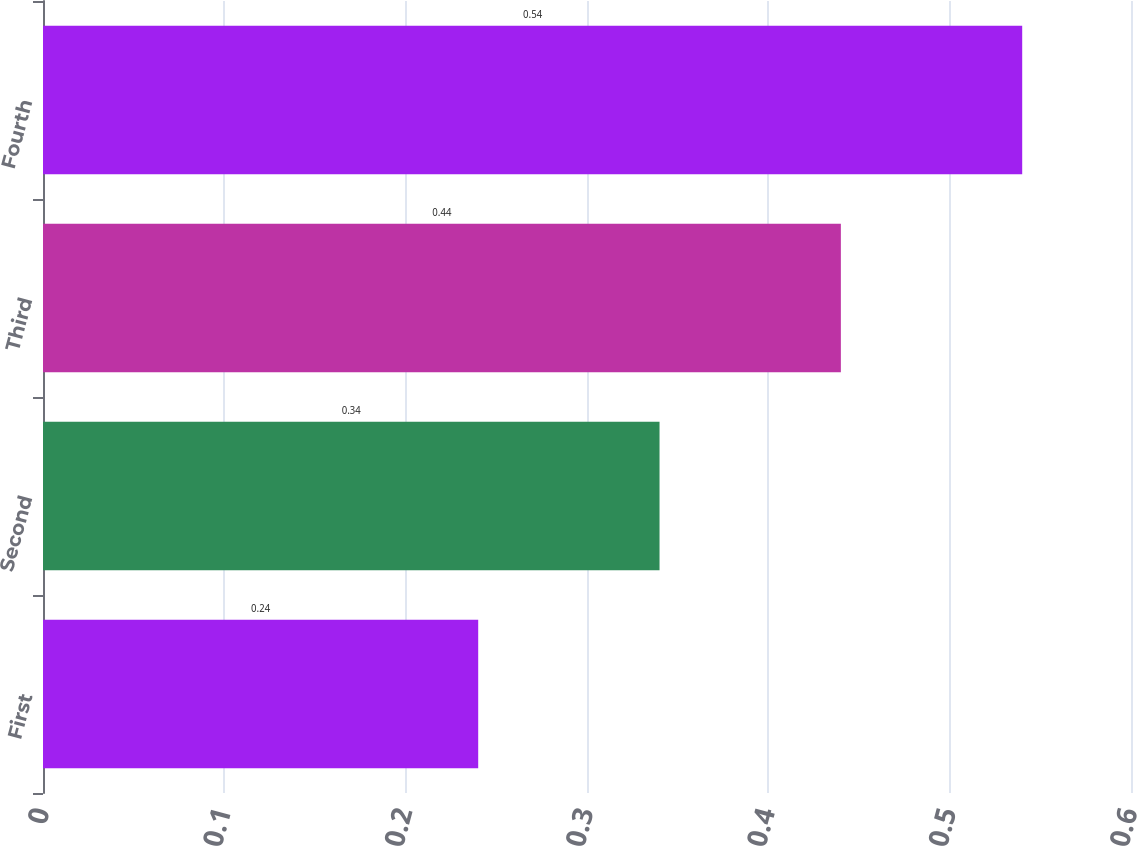Convert chart. <chart><loc_0><loc_0><loc_500><loc_500><bar_chart><fcel>First<fcel>Second<fcel>Third<fcel>Fourth<nl><fcel>0.24<fcel>0.34<fcel>0.44<fcel>0.54<nl></chart> 